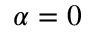Convert formula to latex. <formula><loc_0><loc_0><loc_500><loc_500>\alpha = 0</formula> 